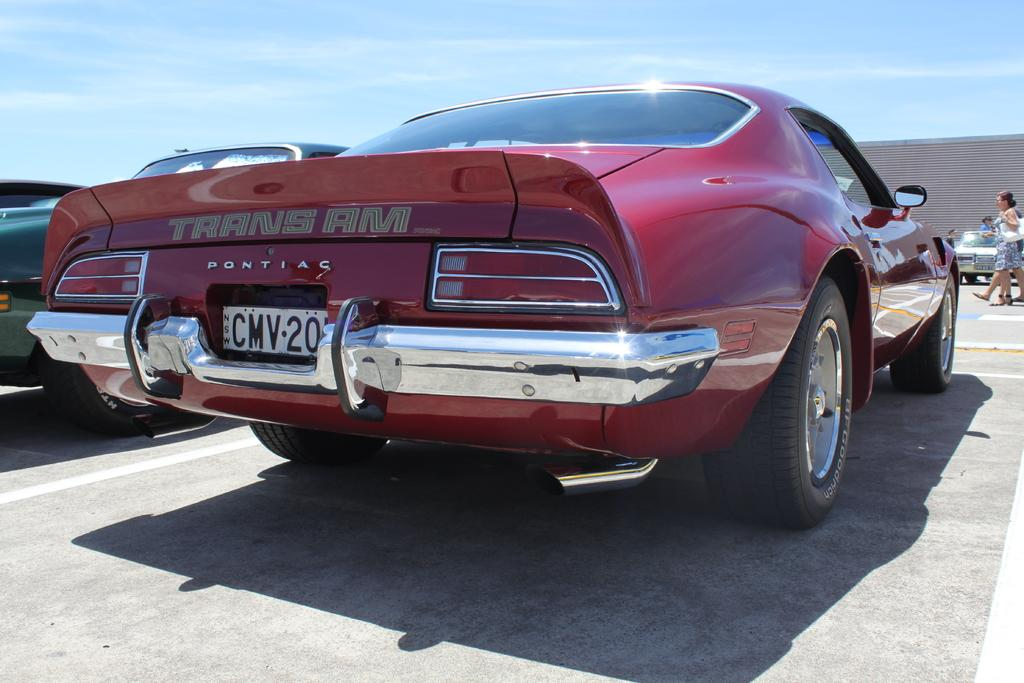What type of vehicles can be seen in the image? There are cars in the image. What are the people in the image doing? The people in the image are walking. What colors are present in the sky in the image? The sky is blue and white in color. What type of club can be seen in the image? There is no club present in the image; it features cars and people walking. What type of machine is being used by the people walking in the image? There is no machine being used by the people walking in the image; they are walking on foot. 